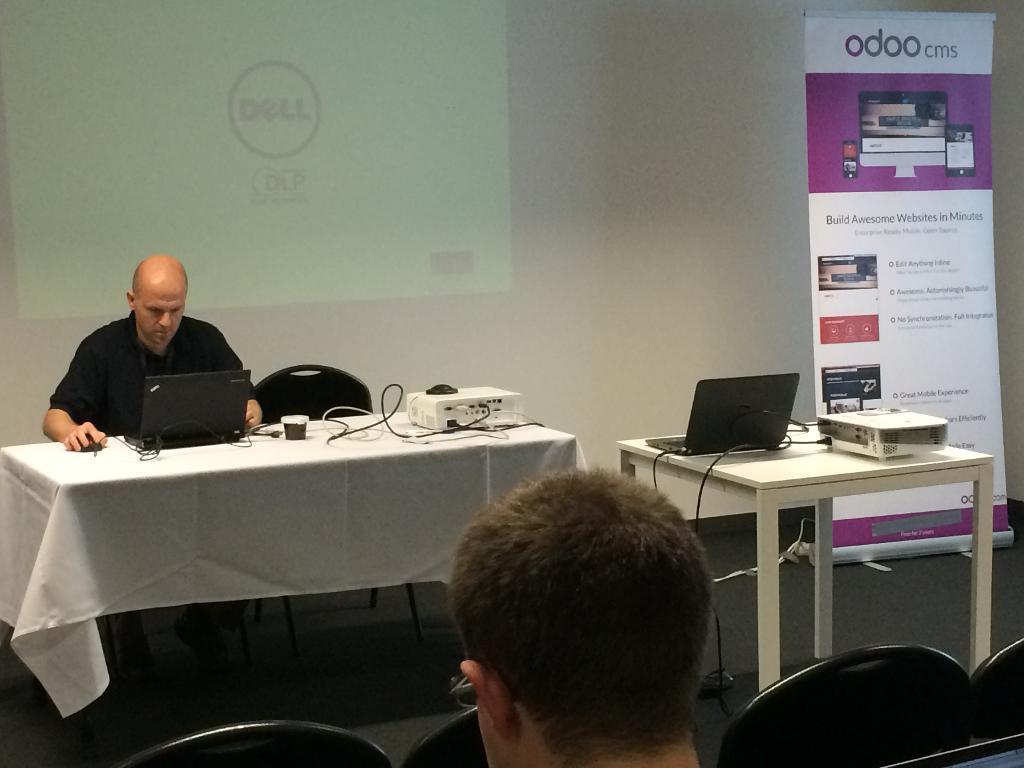Who is present in the image? There is a man in the image. What is the man doing in the image? The man is sitting in the image. What object does the man have with him? The man has a laptop in the image. What is the main focus of the image? There is a project in the image. How many chairs are visible in the image? There are empty chairs in the image. Where is the man sitting in relation to the project? The man is sitting near the project in the image. What type of angle can be seen in the image? There is no angle visible in the image. Can you see a frog in the image? There is no frog present in the image. 